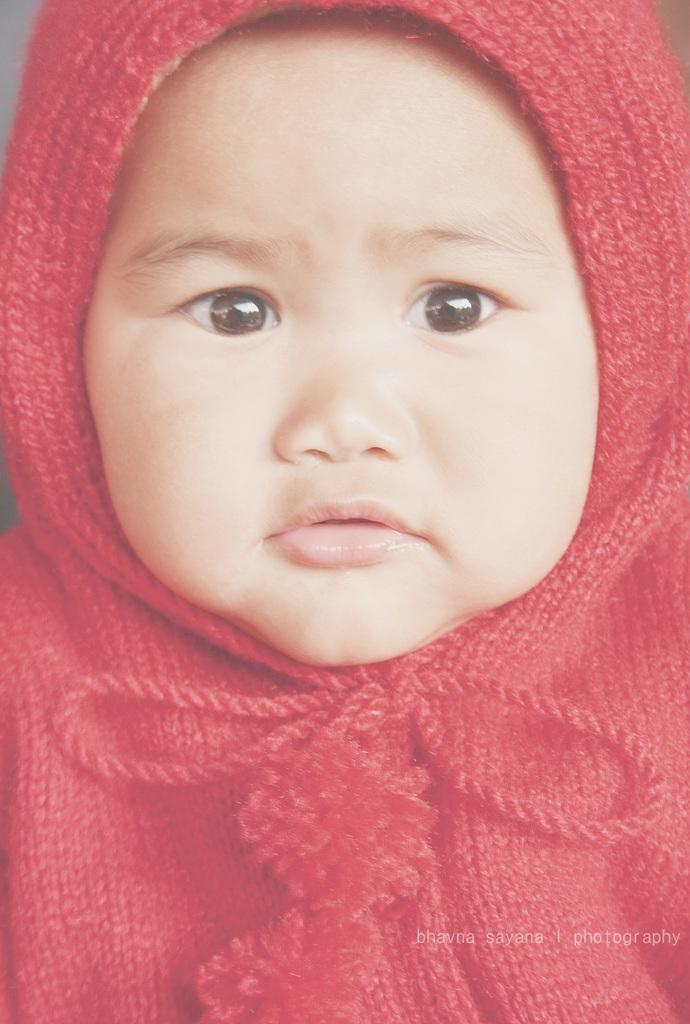What is the main subject of the image? There is a baby in the center of the image. What is the baby wearing? The baby is wearing a red costume. Is there any text or marking on the image? Yes, there is a watermark at the bottom right side of the image. What type of cheese is the baby holding in the image? There is no cheese present in the image; the baby is not holding anything. How many eyes does the chicken have in the image? There is no chicken present in the image. 